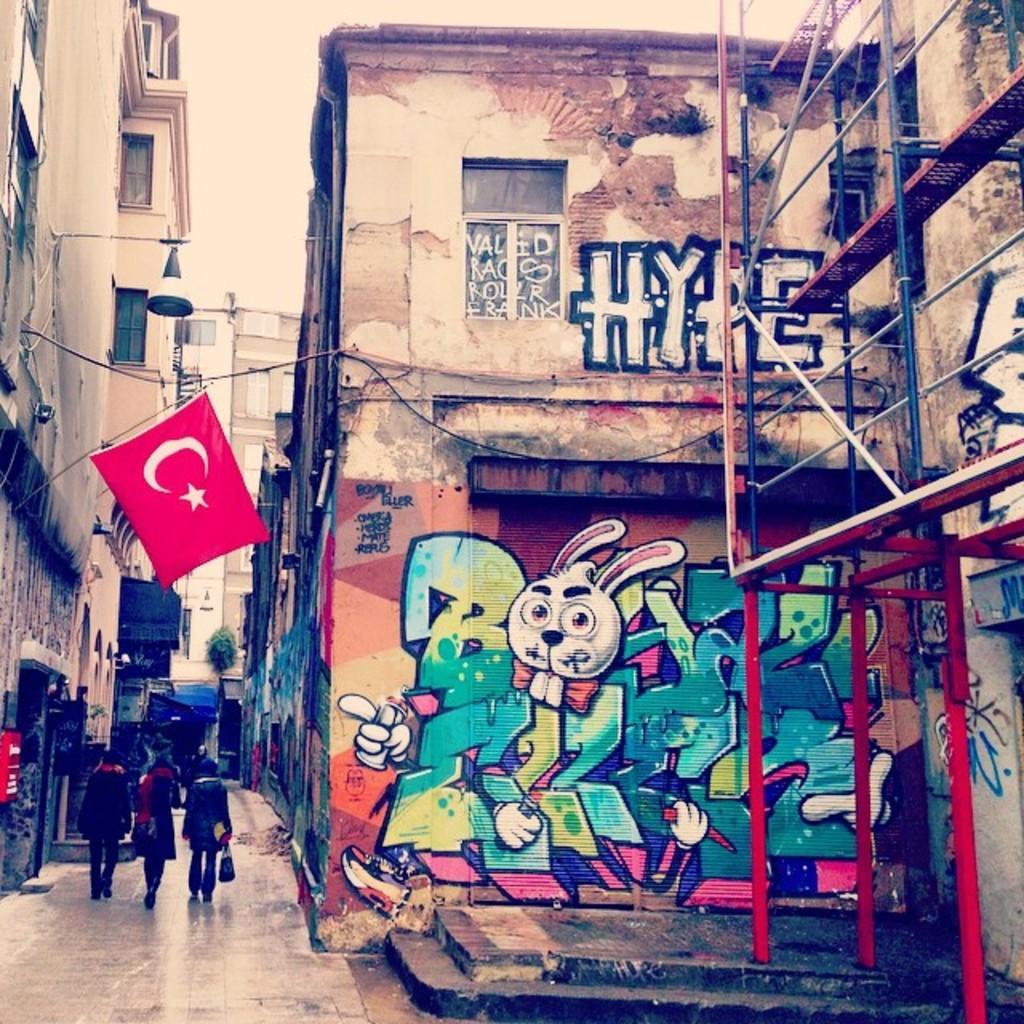Please provide a concise description of this image. In this image we can see buildings with windows. On the building there is graffiti. On the right side there is a stand with rods. There are few people walking. Also there is a flag on the building. And there are few other things. 